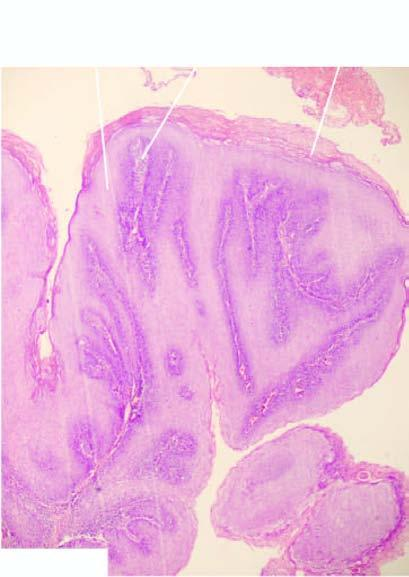what is there?
Answer the question using a single word or phrase. Papillomatosis 